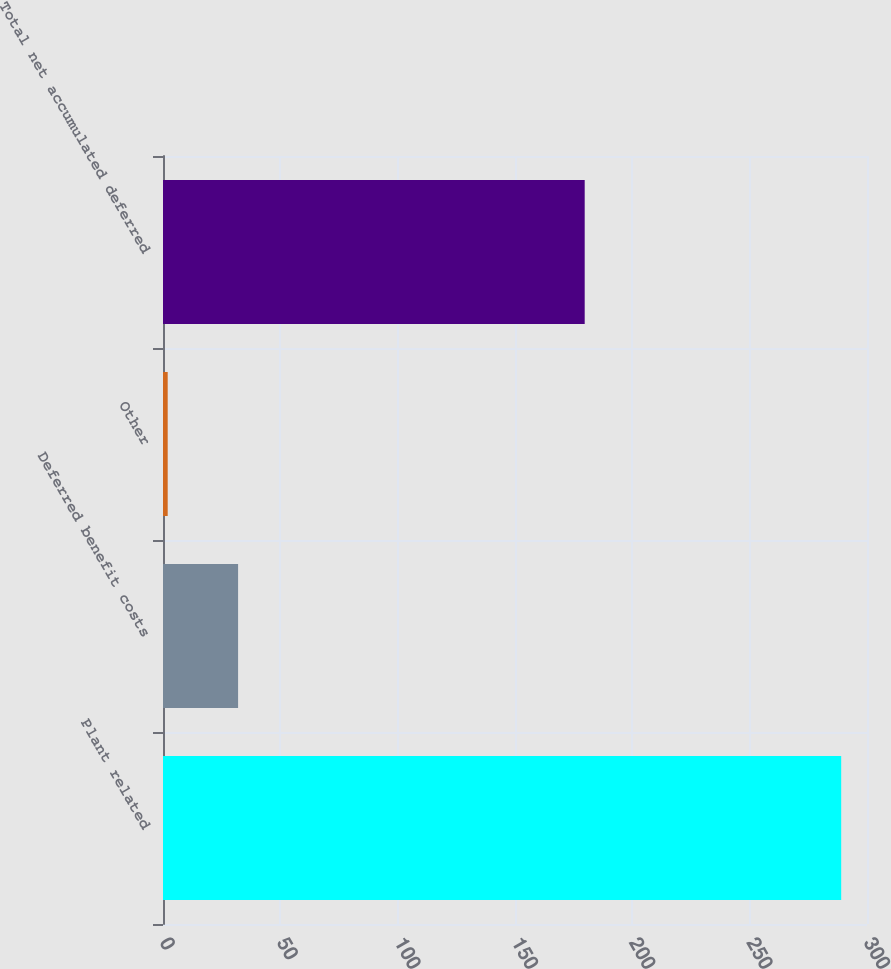<chart> <loc_0><loc_0><loc_500><loc_500><bar_chart><fcel>Plant related<fcel>Deferred benefit costs<fcel>Other<fcel>Total net accumulated deferred<nl><fcel>289<fcel>32<fcel>2<fcel>179.7<nl></chart> 